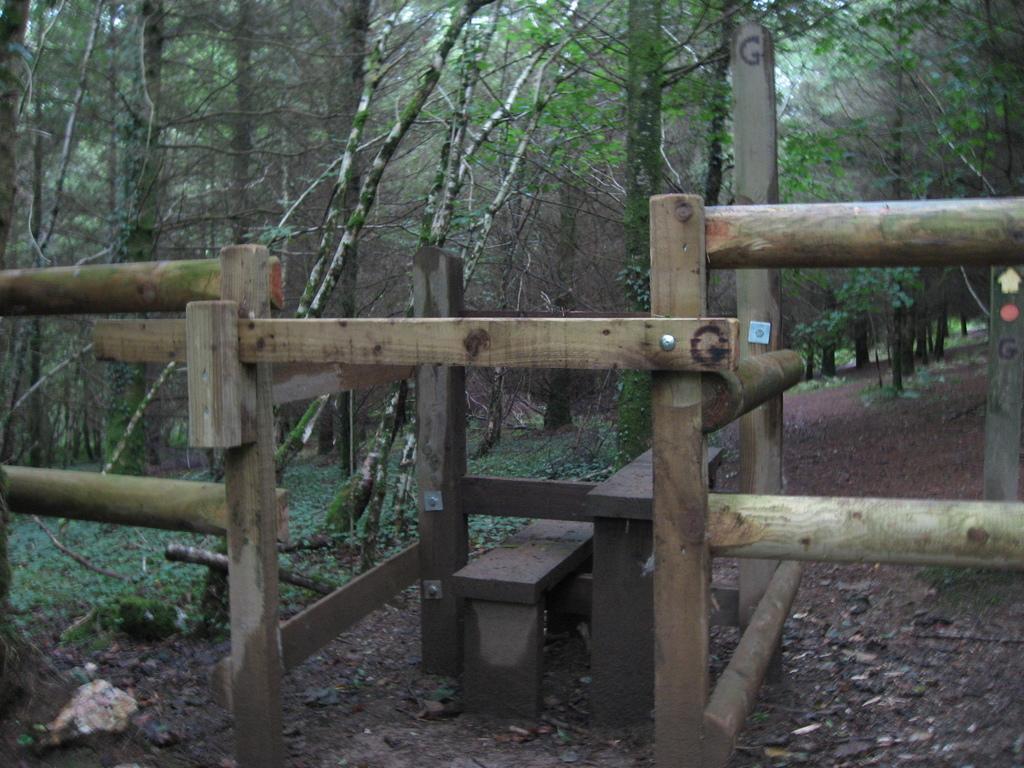Could you give a brief overview of what you see in this image? These are green color trees, this is wooden structure. 